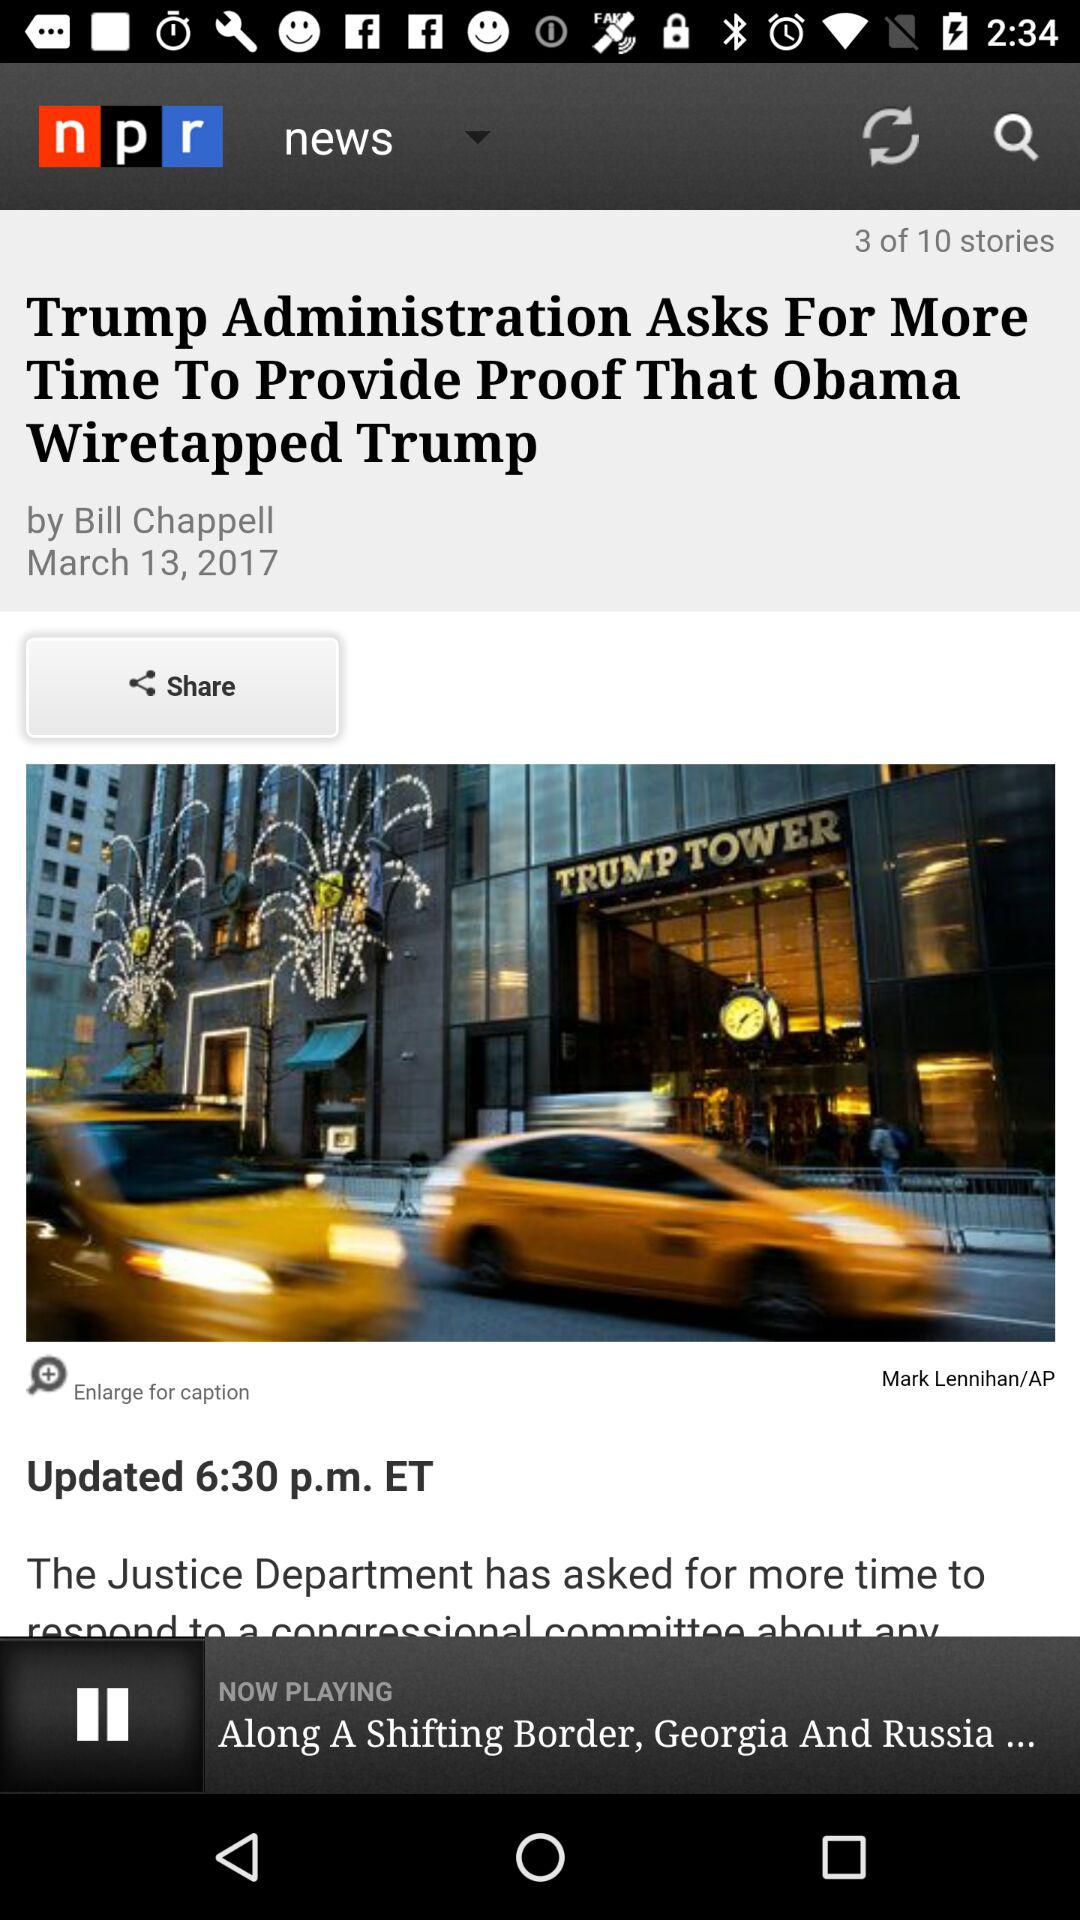What is the page number of the article? The page number is 3. 